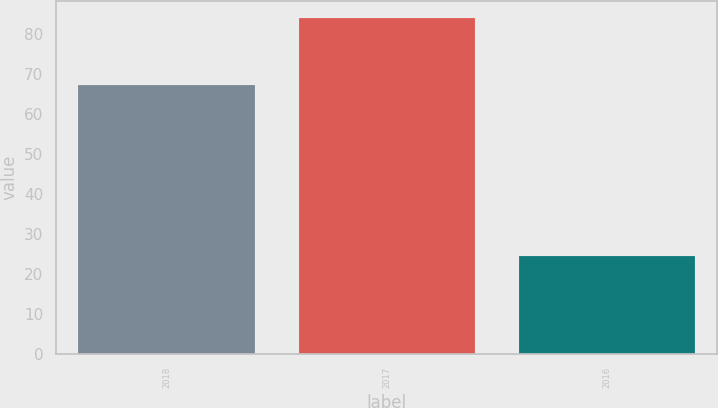Convert chart to OTSL. <chart><loc_0><loc_0><loc_500><loc_500><bar_chart><fcel>2018<fcel>2017<fcel>2016<nl><fcel>67.2<fcel>84<fcel>24.6<nl></chart> 